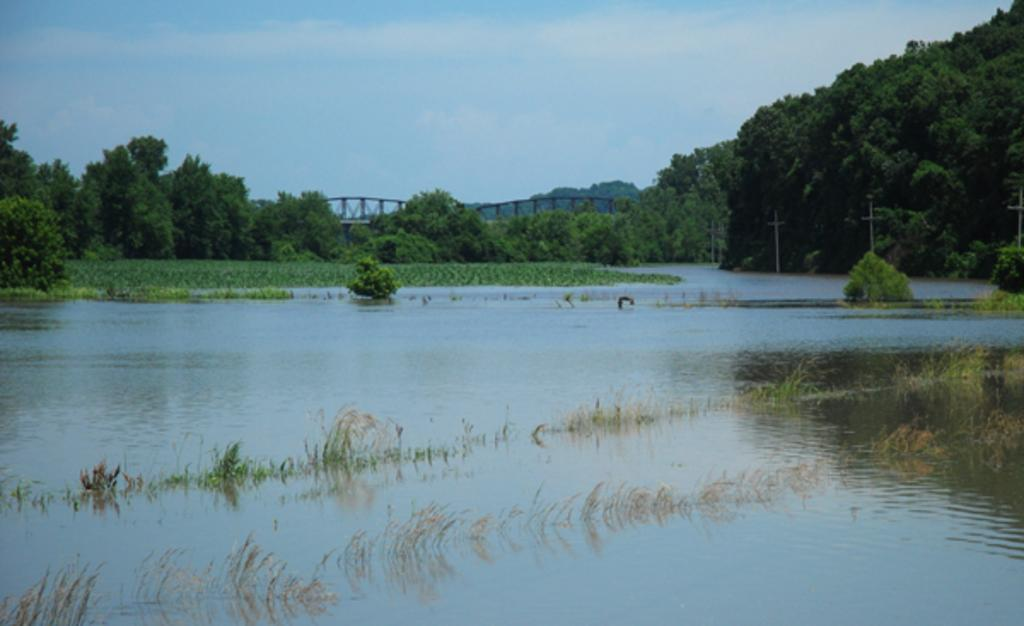What is present at the bottom of the image? There is water at the bottom of the image. What can be seen in the background of the image? There are trees and a bridge in the background of the image. What is visible in the sky in the image? The sky is visible in the background of the image. Where is the bell hanging in the image? There is no bell present in the image. What type of basket can be seen in the image? There is no basket present in the image. 